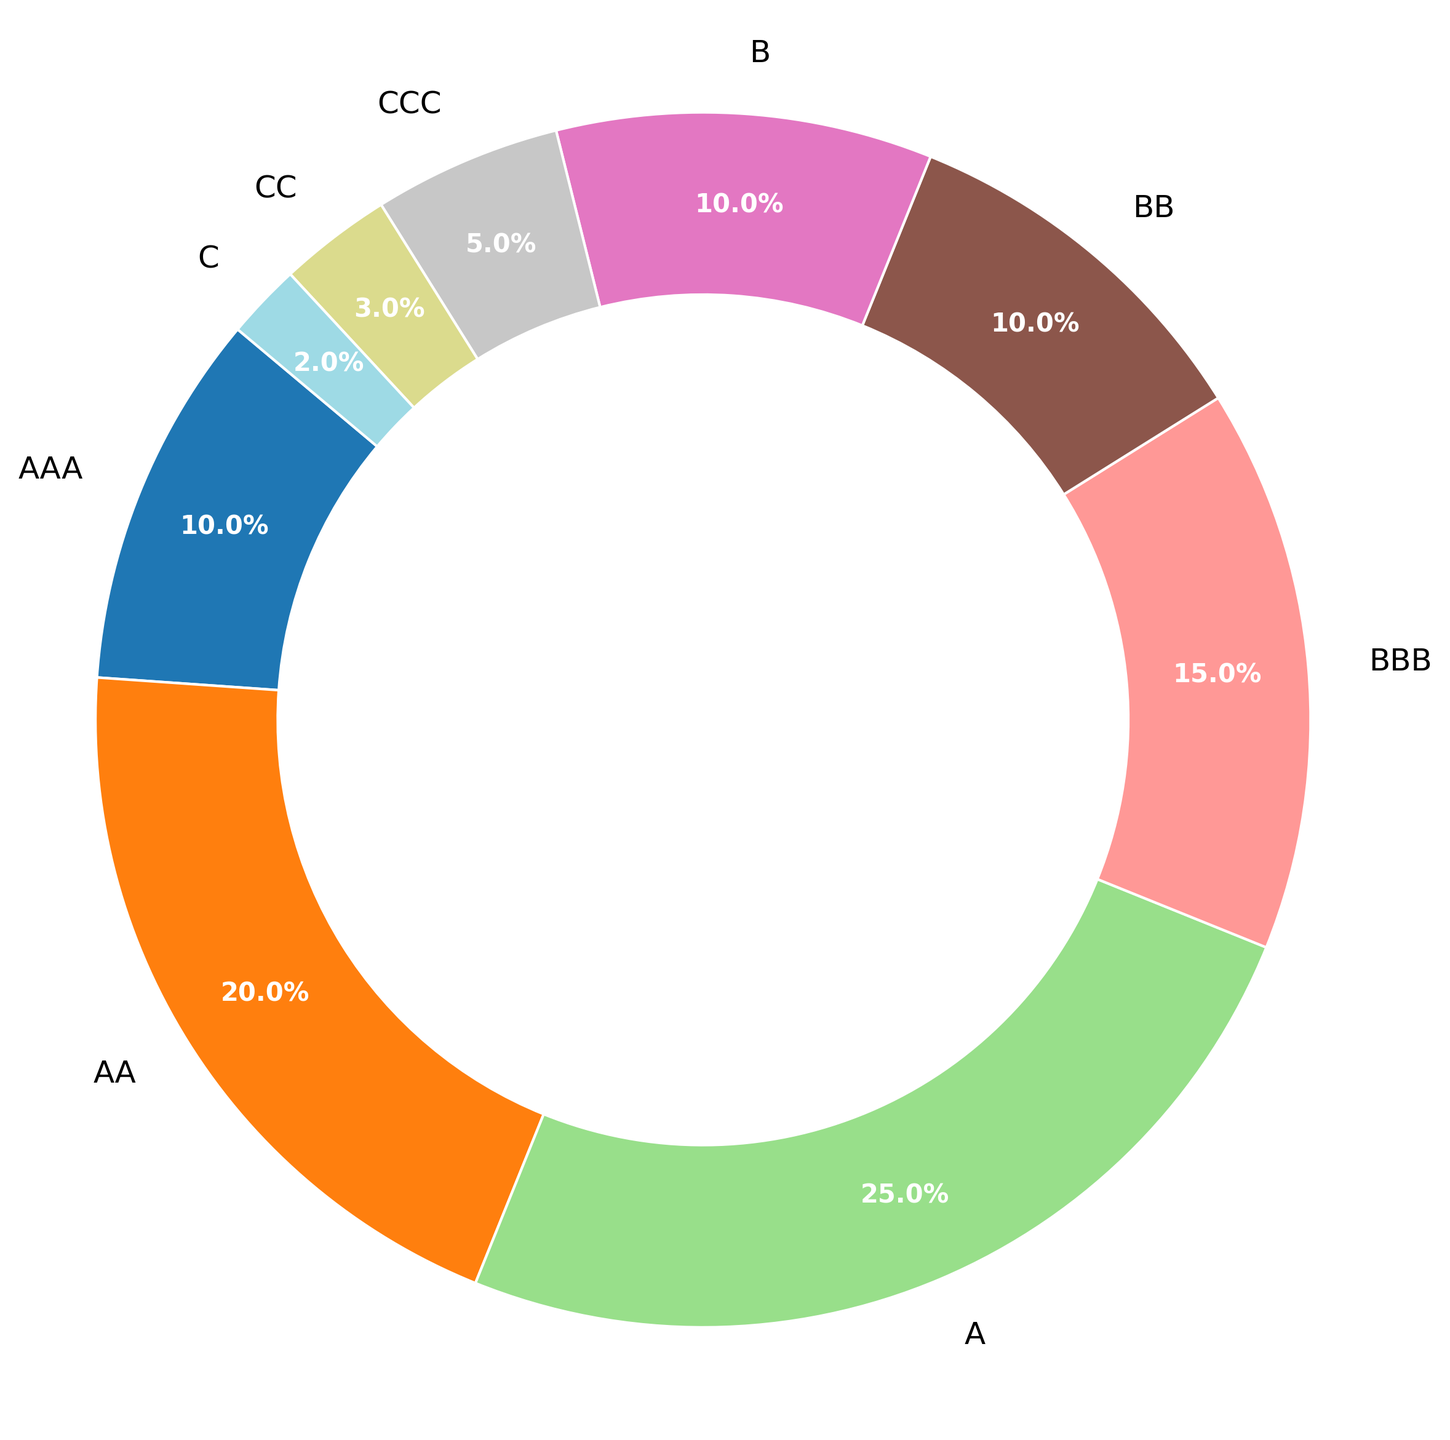What is the percentage of loans rated A or higher? To find this, sum the percentages of the categories AAA, AA, and A. AAA is 10%, AA is 20%, and A is 25%. So, 10% + 20% + 25% = 55%.
Answer: 55% Which credit rating has the highest percentage in the loan portfolio? Examine the chart to find the slice with the largest percentage. A has the highest percentage at 25%.
Answer: A How much larger is the AA category compared to the BB category? The AA category is 20% and the BB category is 10%. Calculate the difference: 20% - 10% = 10%.
Answer: 10% What is the combined percentage of the three lowest-rated credit categories? The three lowest-rated categories are C, CC, and CCC. Their percentages are 2%, 3%, and 5%, respectively. Sum these values: 2% + 3% + 5% = 10%.
Answer: 10% Is the percentage of BBB-rated loans greater than the combined percentage of C and CC-rated loans? BBB is 15%, and the combined percentage of C and CC is 2% + 3% = 5%. Compare the two: 15% is greater than 5%.
Answer: Yes Rank the credit rating categories from highest to lowest percentage. Review the chart and list the categories in descending order based on their percentages: A (25%), AA (20%), BBB (15%), AAA (10%), BB (10%), B (10%), CCC (5%), CC (3%), C (2%).
Answer: A, AA, BBB, AAA, BB, B, CCC, CC, C What is the difference between the percentages of AAA and CCC-rated loans? AAA is 10% and CCC is 5%. Calculate the difference: 10% - 5% = 5%.
Answer: 5% Which categories have an equal percentage of loans? Look for categories with the same percentage value in the chart. AAA, BB, and B each have 10%.
Answer: AAA, BB, B 